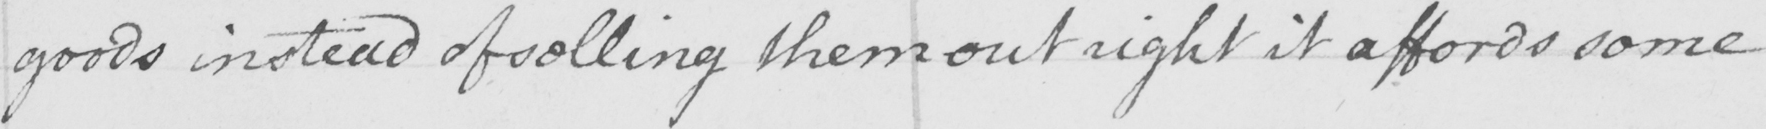Can you read and transcribe this handwriting? goods instead of selling them out right it affords some 